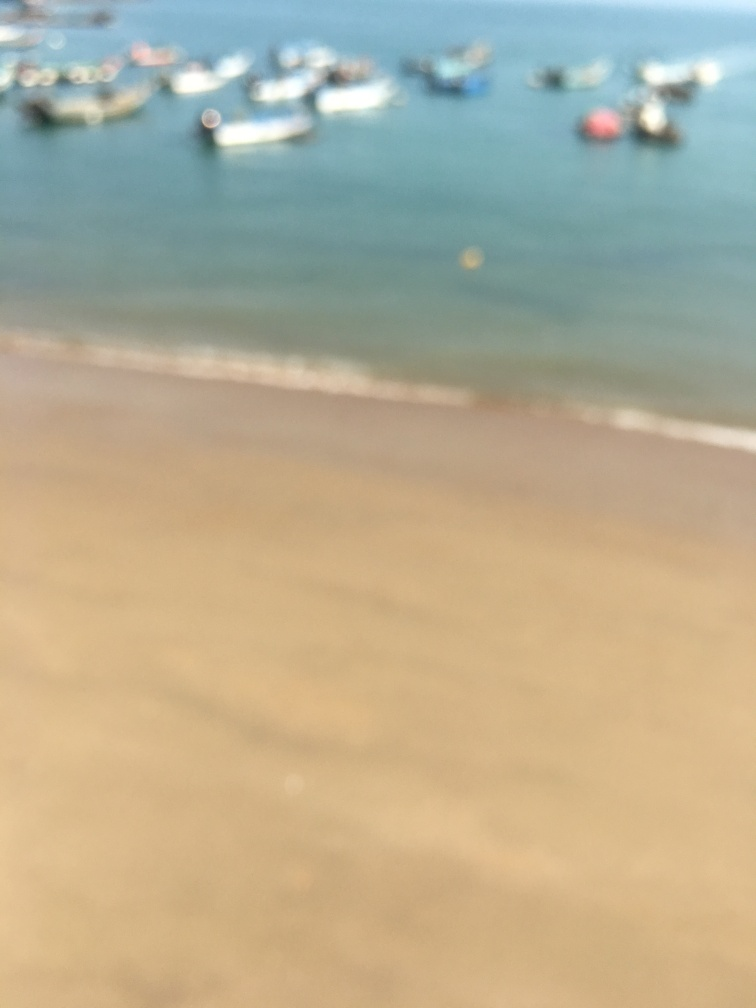Can you describe the overall atmosphere or vibe of this image? Though the image is blurry, it imparts a tranquil and serene vibe, potentially of a quiet beach scene with several boats suggesting a leisurely or fishing activity. The softness of focus may also give the viewer a feeling of reminiscence or dreaminess. 